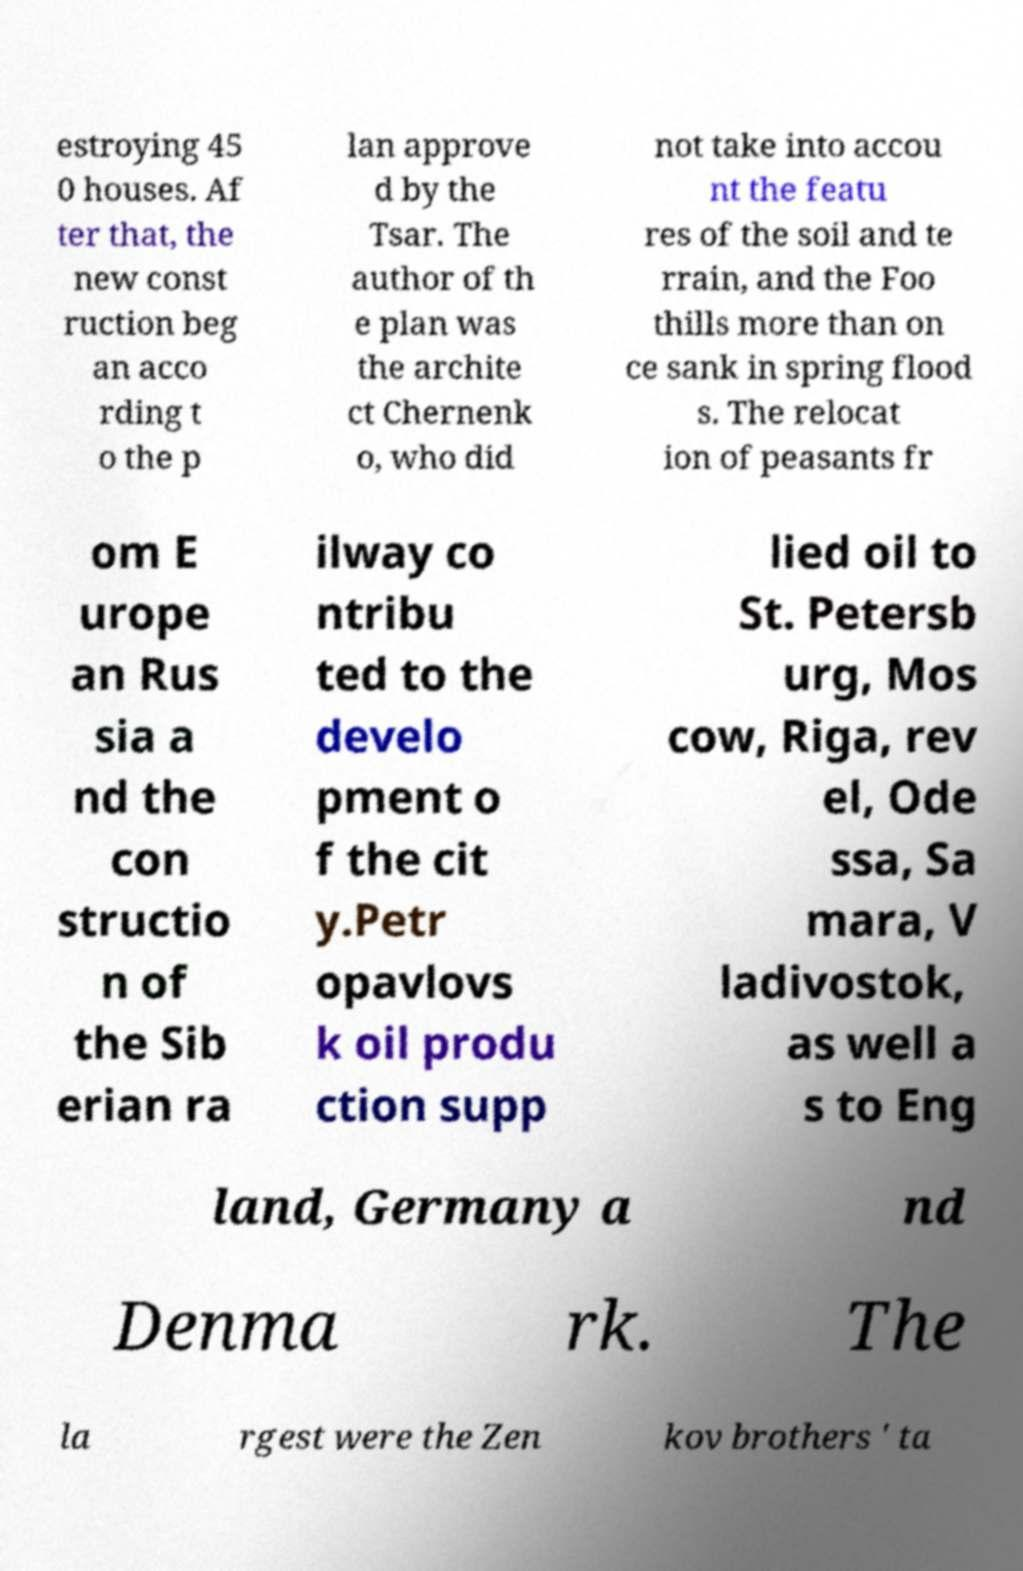I need the written content from this picture converted into text. Can you do that? estroying 45 0 houses. Af ter that, the new const ruction beg an acco rding t o the p lan approve d by the Tsar. The author of th e plan was the archite ct Chernenk o, who did not take into accou nt the featu res of the soil and te rrain, and the Foo thills more than on ce sank in spring flood s. The relocat ion of peasants fr om E urope an Rus sia a nd the con structio n of the Sib erian ra ilway co ntribu ted to the develo pment o f the cit y.Petr opavlovs k oil produ ction supp lied oil to St. Petersb urg, Mos cow, Riga, rev el, Ode ssa, Sa mara, V ladivostok, as well a s to Eng land, Germany a nd Denma rk. The la rgest were the Zen kov brothers ' ta 